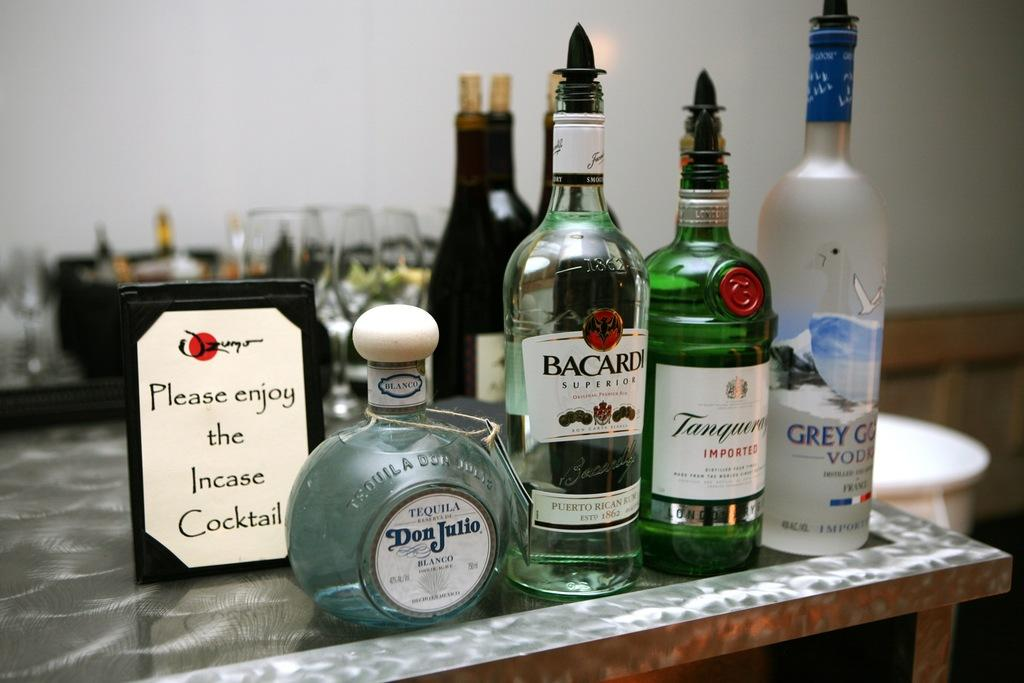What can be seen in the background of the picture? There is a wall in the background of the picture. What objects are on the table in the image? There are different bottles and a board on the table. Can you describe the arrangement of the glasses in the image? Glasses are visible behind the bottles on the table. What type of growth can be observed on the bottles in the image? There is no growth visible on the bottles in the image. What trip is being planned by the objects in the image? The objects in the image are not planning a trip, as they are inanimate. 